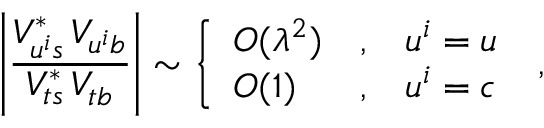Convert formula to latex. <formula><loc_0><loc_0><loc_500><loc_500>\left | \frac { V _ { u ^ { i } s } ^ { \ast } \, V _ { u ^ { i } b } } { V _ { t s } ^ { \ast } \, V _ { t b } } \right | \sim \left \{ \begin{array} { l c l } { { O ( \lambda ^ { 2 } ) } } & { , } & { { u ^ { i } = u } } \\ { O ( 1 ) } & { , } & { { u ^ { i } = c } } \end{array} \, ,</formula> 